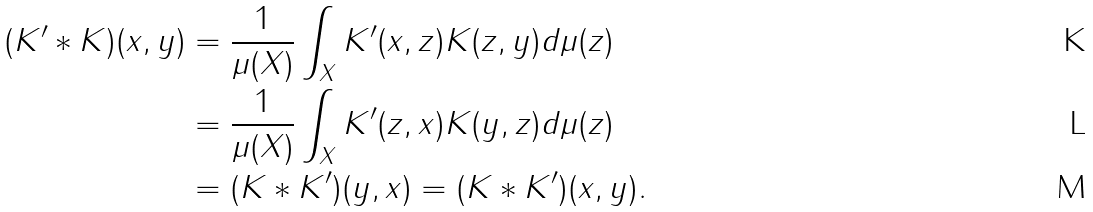<formula> <loc_0><loc_0><loc_500><loc_500>( K ^ { \prime } * K ) ( x , y ) & = \frac { 1 } { \mu ( X ) } \int _ { X } K ^ { \prime } ( x , z ) K ( z , y ) d \mu ( z ) \\ & = \frac { 1 } { \mu ( X ) } \int _ { X } K ^ { \prime } ( z , x ) K ( y , z ) d \mu ( z ) \\ & = ( K * K ^ { \prime } ) ( y , x ) = ( K * K ^ { \prime } ) ( x , y ) .</formula> 